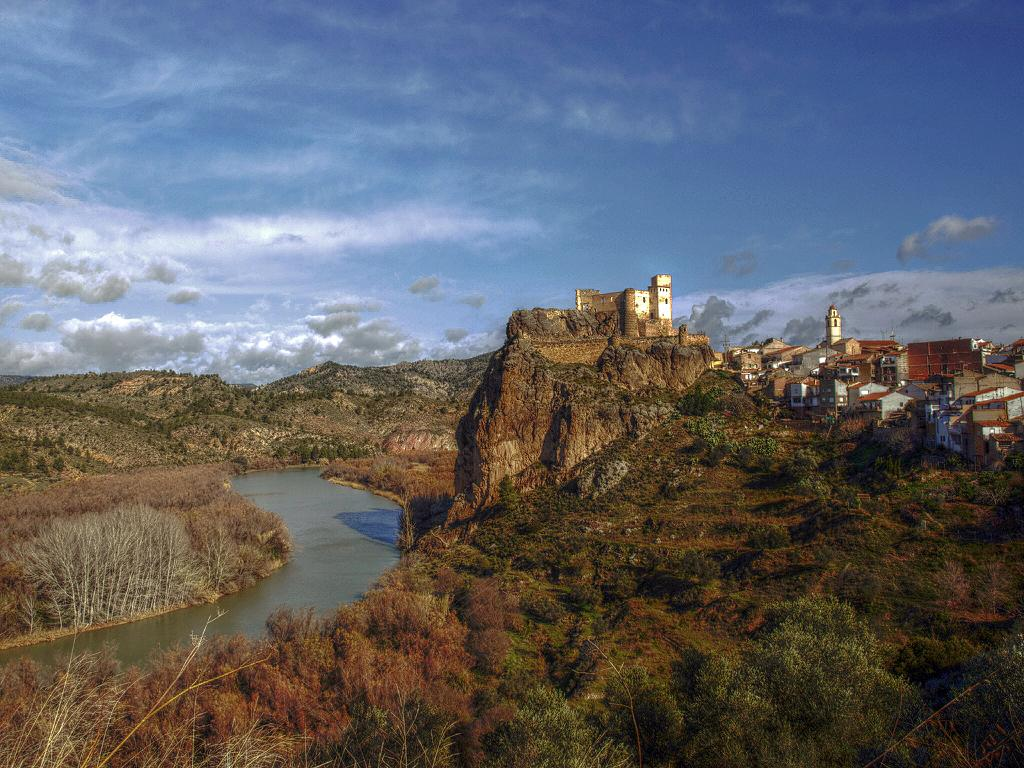What type of living organisms can be seen in the image? Plants can be seen in the image. What color are the plants in the image? The plants are green in color. What else is visible in the image besides the plants? There is water visible in the image. What can be seen in the background of the image? There are buildings in the background of the image. What is the color of the sky in the image? The sky is blue and white in color. What type of beast can be seen roaming in the image? There is no beast present in the image; it features plants, water, buildings, and a blue and white sky. 